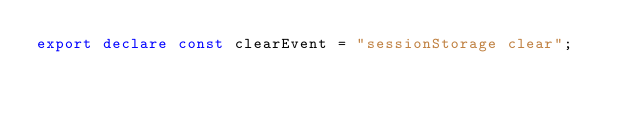<code> <loc_0><loc_0><loc_500><loc_500><_TypeScript_>export declare const clearEvent = "sessionStorage clear";
</code> 